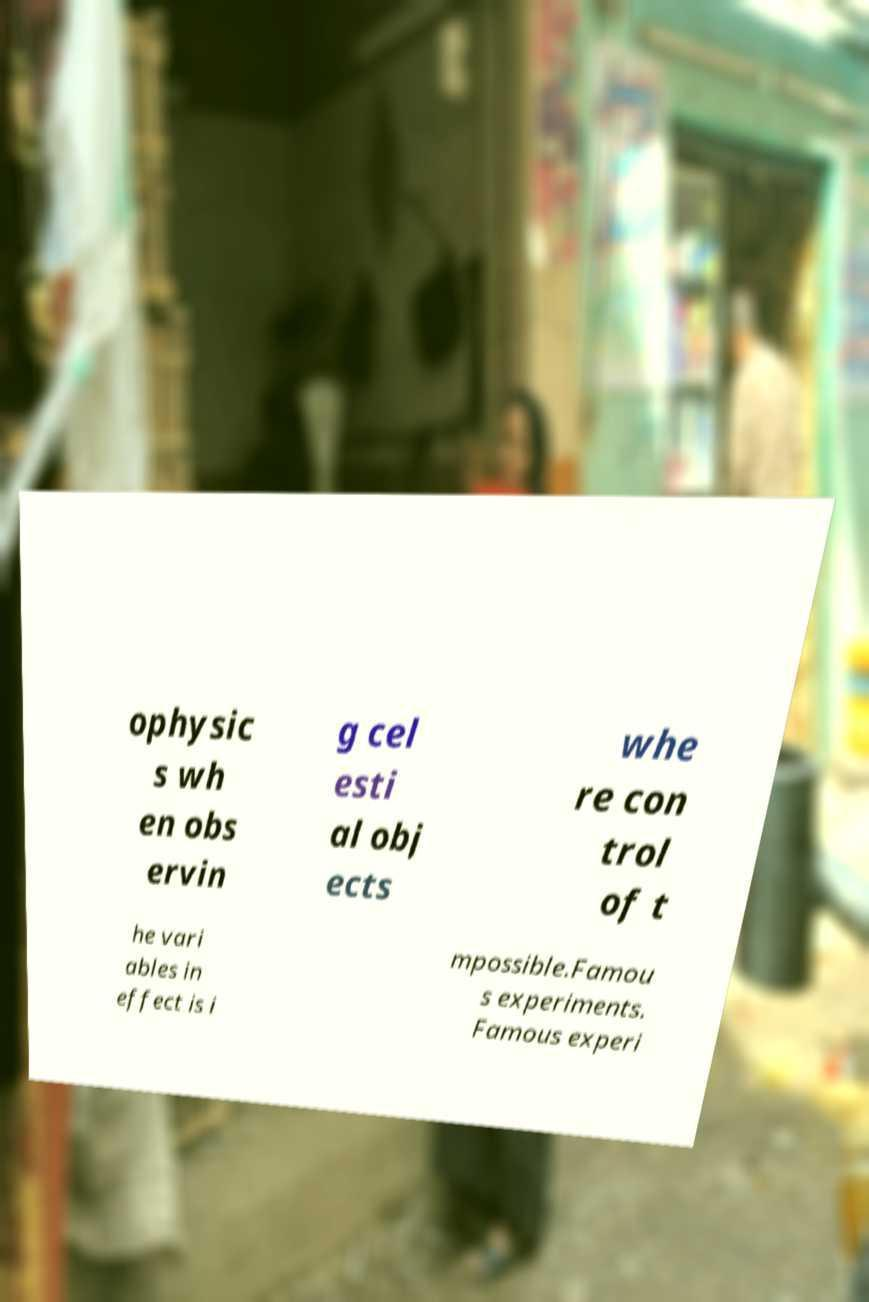What messages or text are displayed in this image? I need them in a readable, typed format. ophysic s wh en obs ervin g cel esti al obj ects whe re con trol of t he vari ables in effect is i mpossible.Famou s experiments. Famous experi 